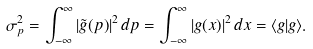<formula> <loc_0><loc_0><loc_500><loc_500>\sigma _ { p } ^ { 2 } = \int _ { - \infty } ^ { \infty } | { \tilde { g } } ( p ) | ^ { 2 } \, d p = \int _ { - \infty } ^ { \infty } | g ( x ) | ^ { 2 } \, d x = \langle g | g \rangle .</formula> 